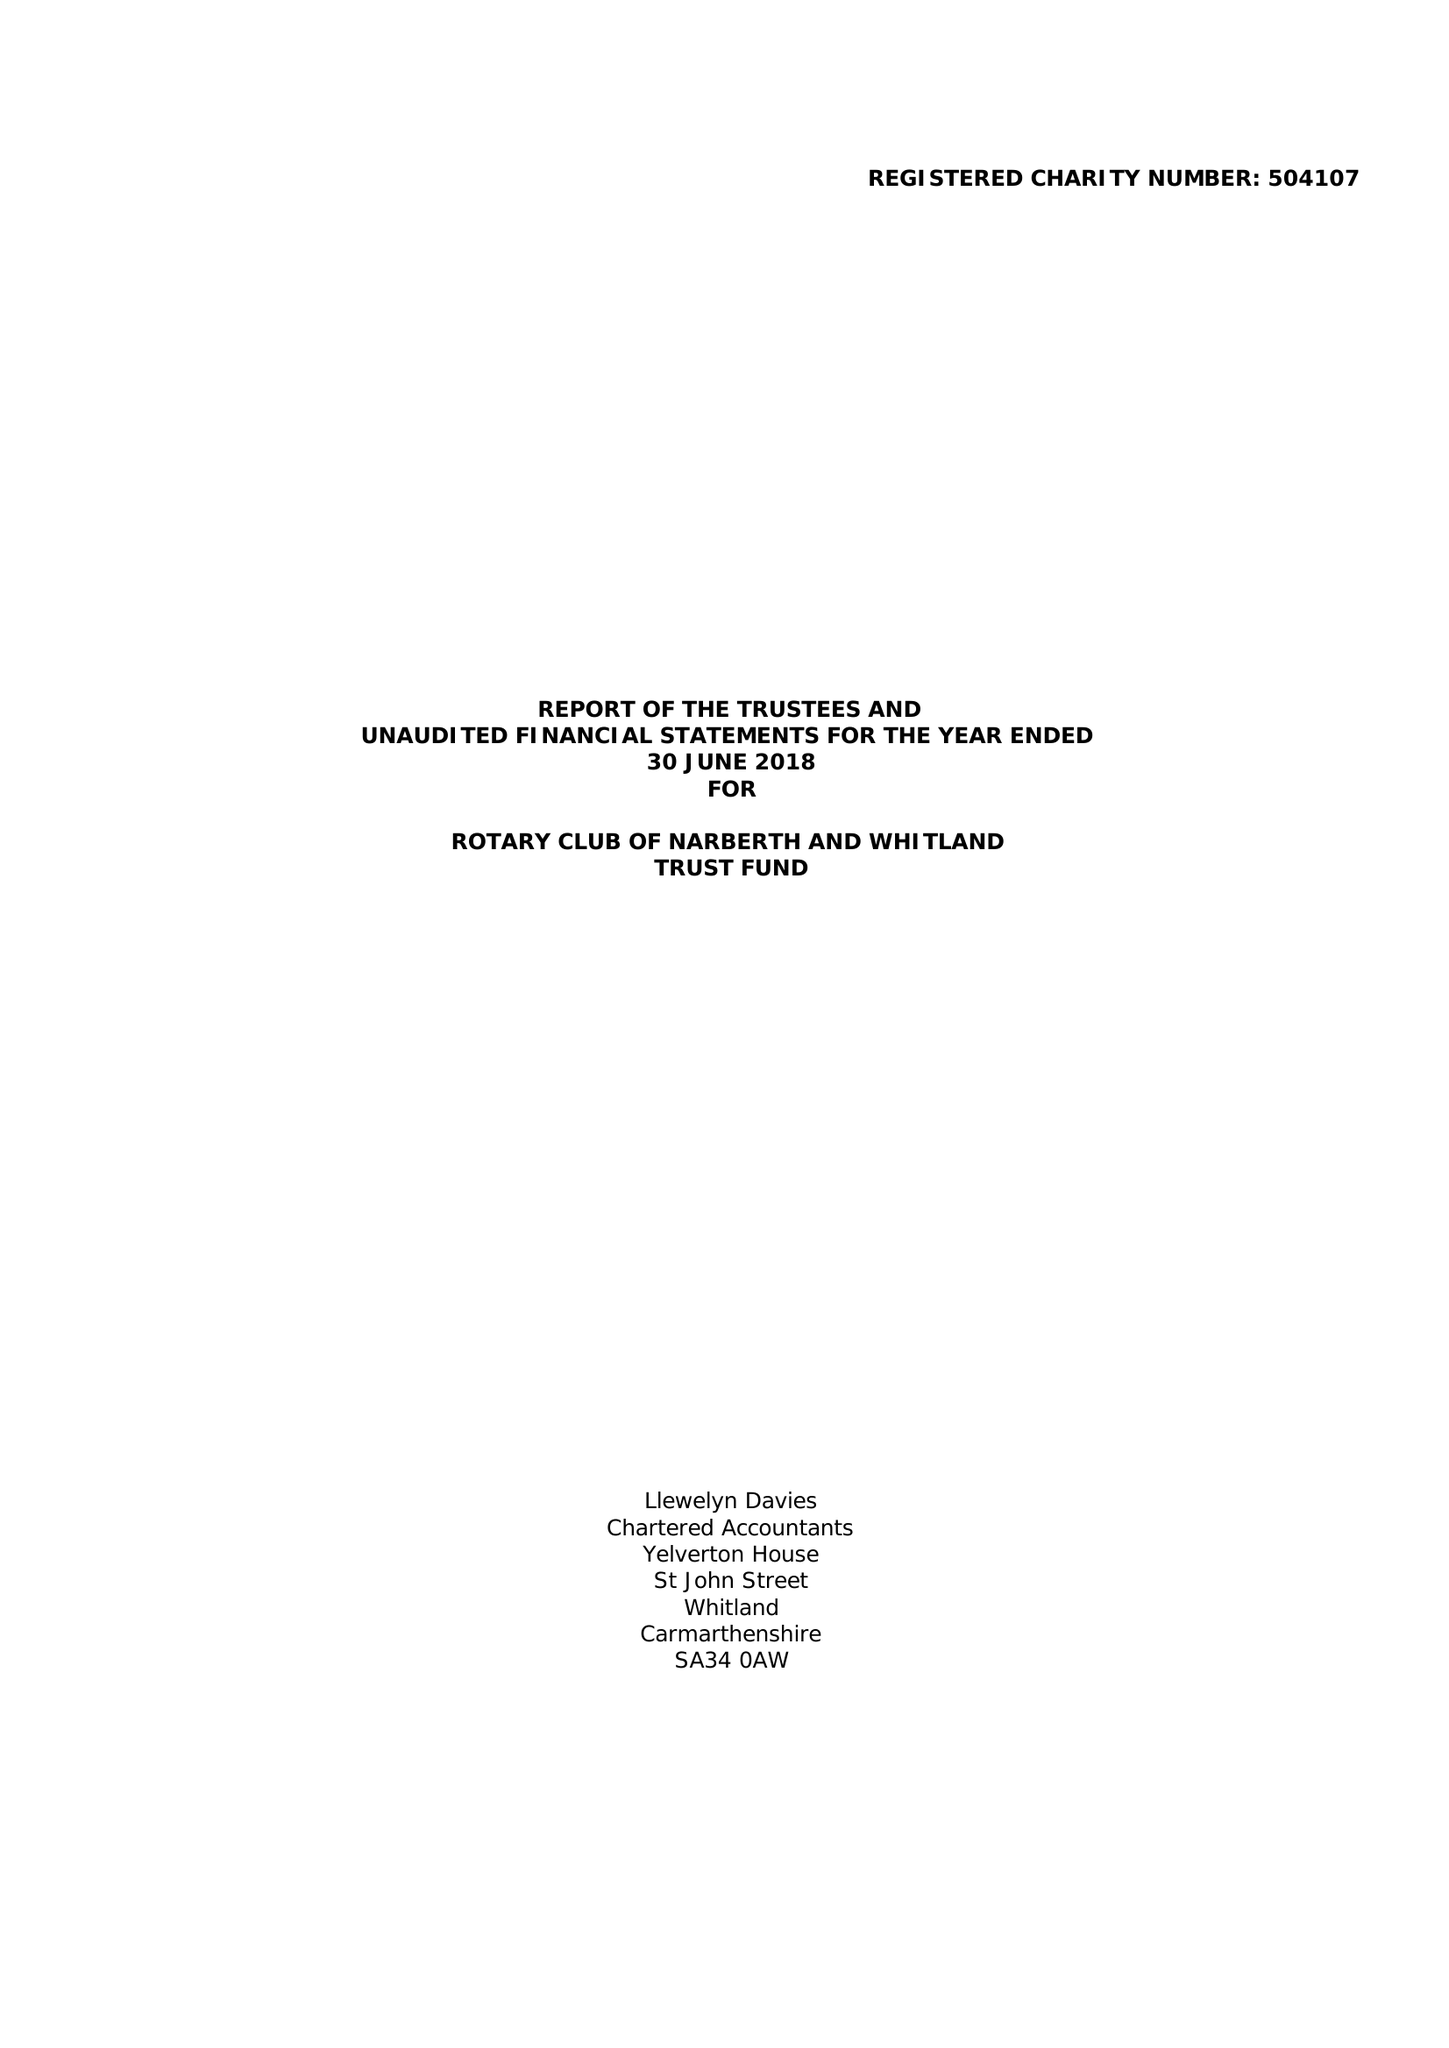What is the value for the report_date?
Answer the question using a single word or phrase. 2018-06-30 